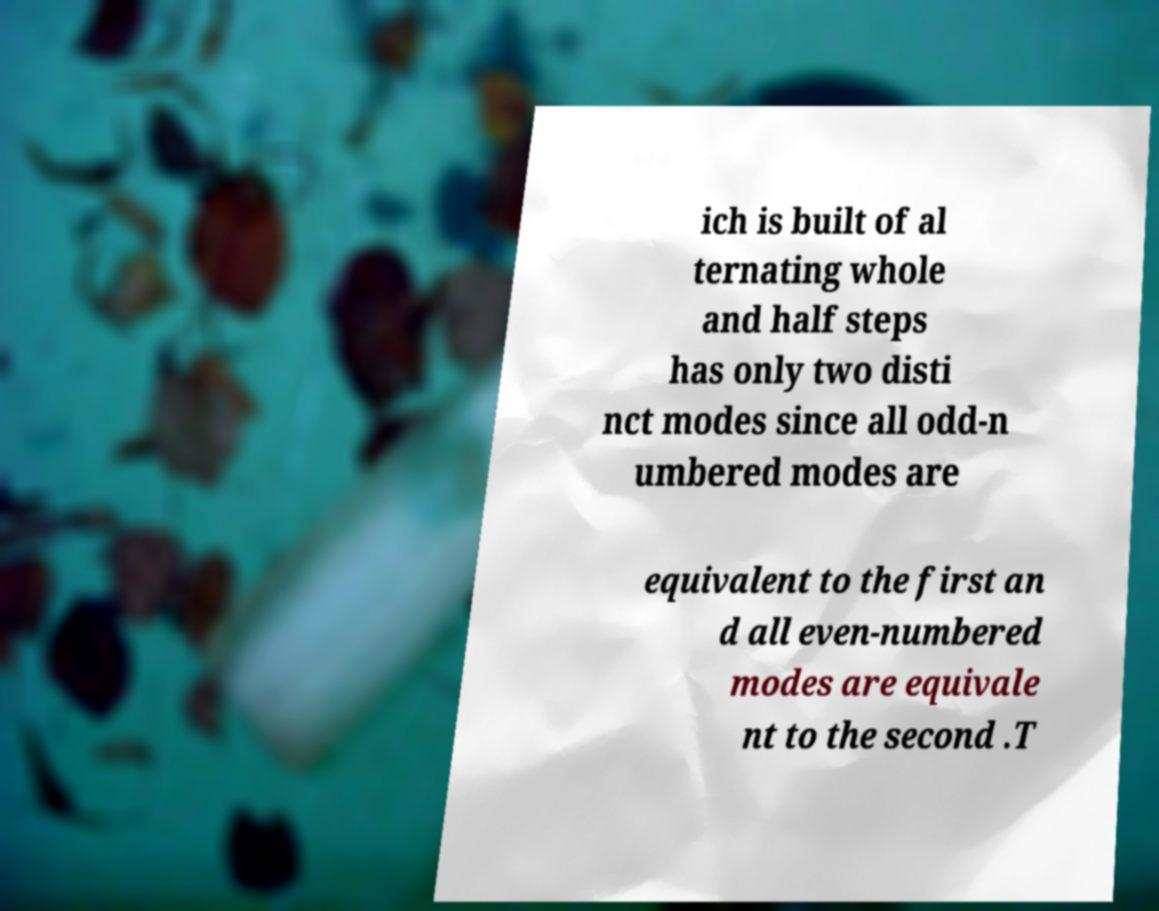Please read and relay the text visible in this image. What does it say? ich is built of al ternating whole and half steps has only two disti nct modes since all odd-n umbered modes are equivalent to the first an d all even-numbered modes are equivale nt to the second .T 